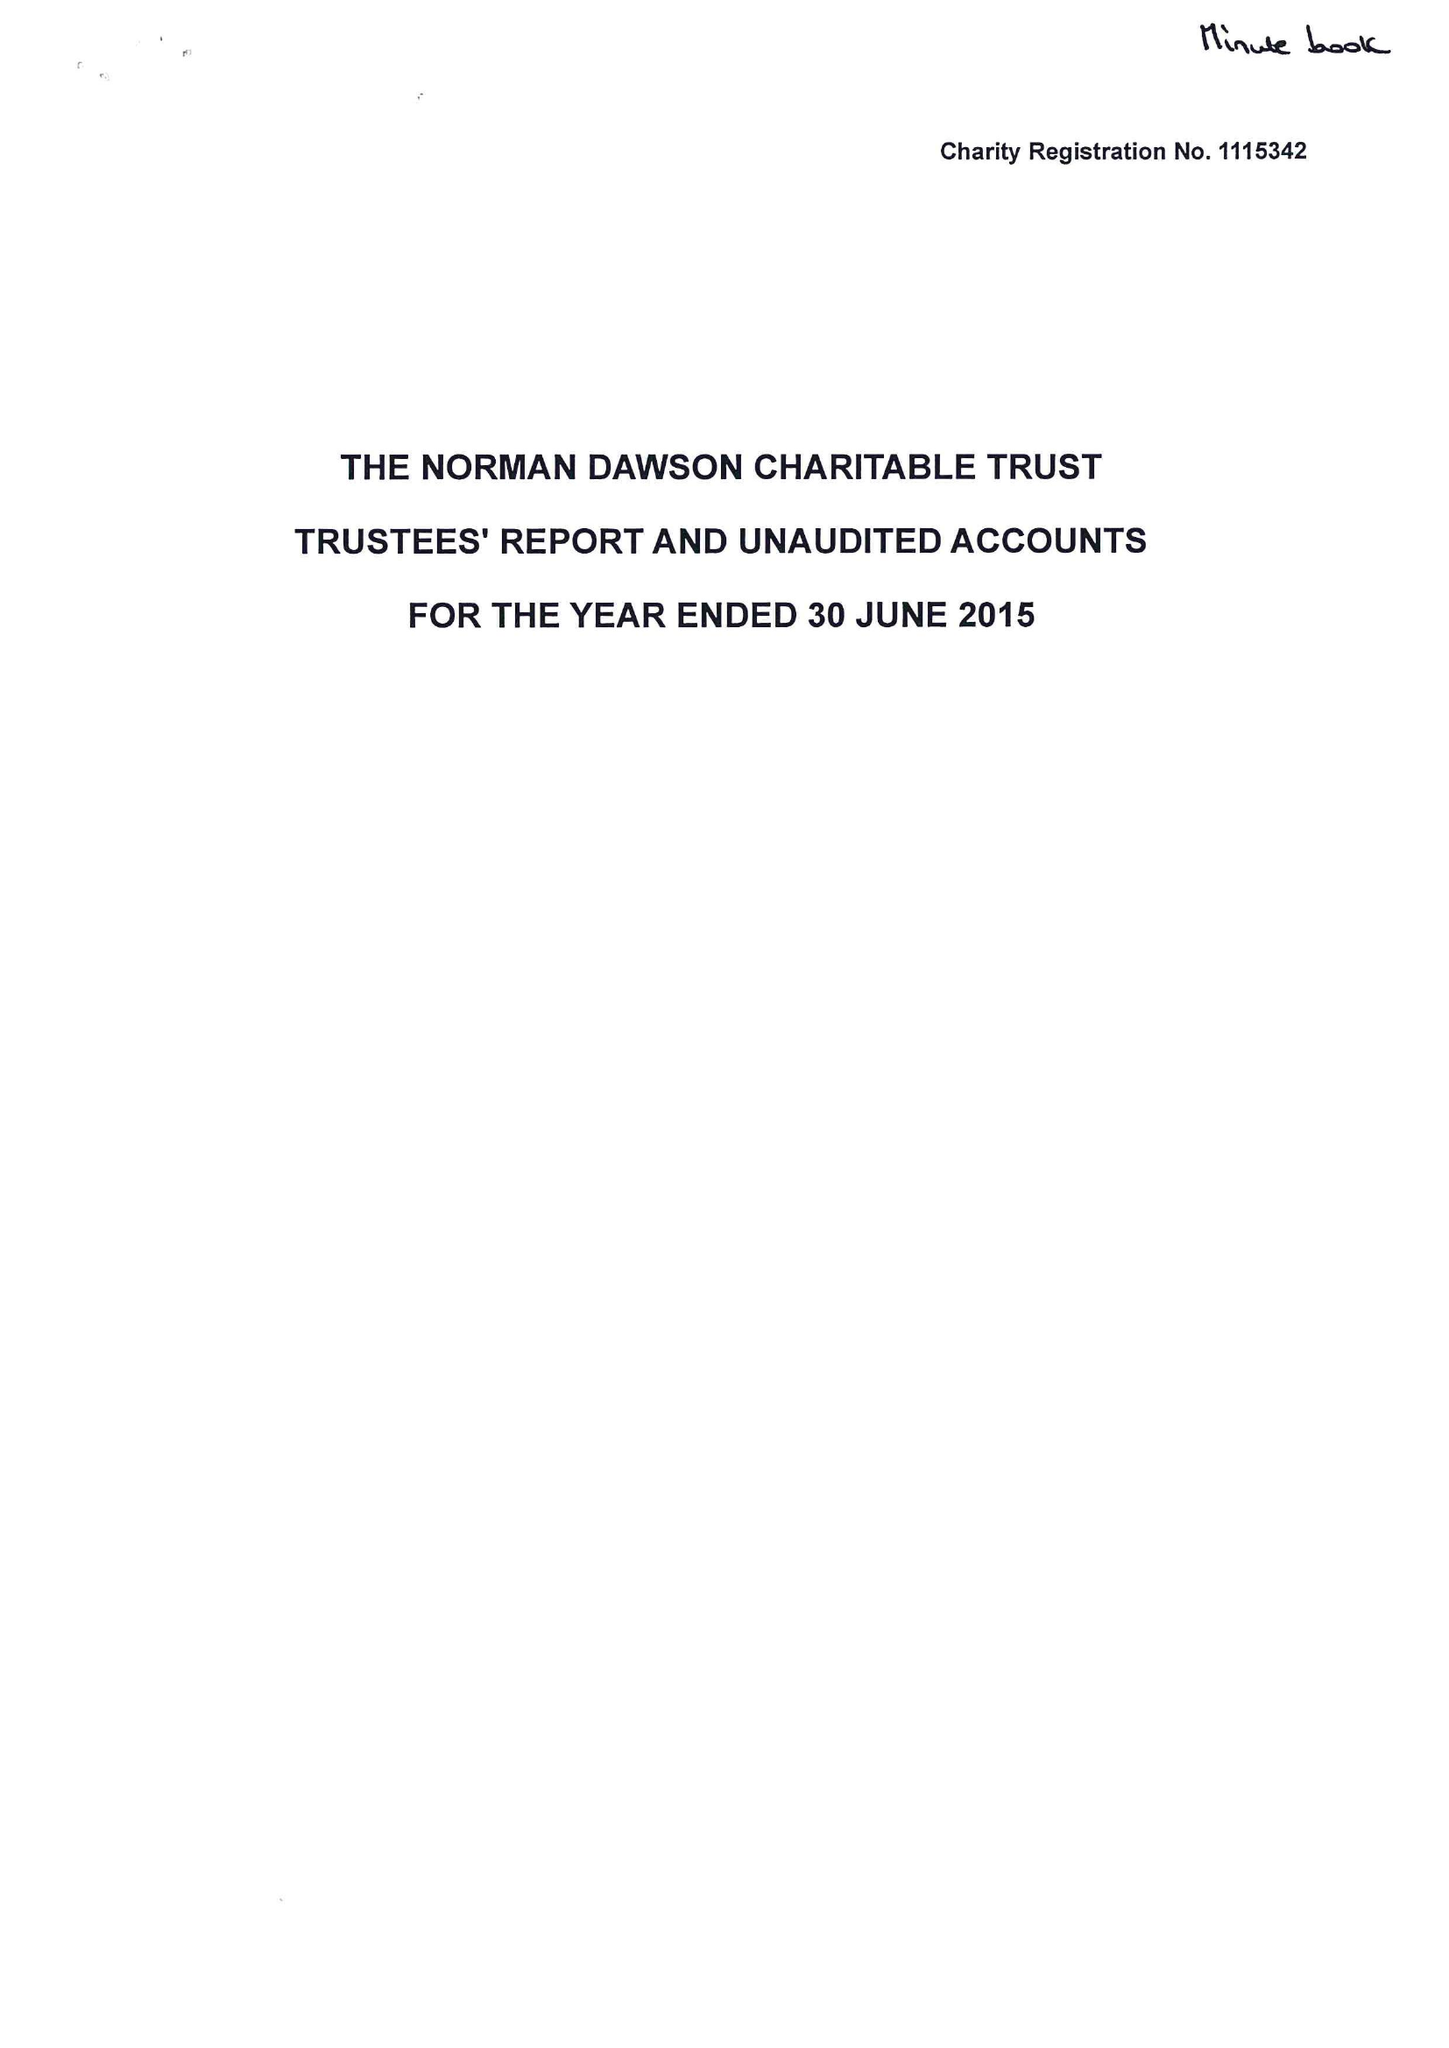What is the value for the report_date?
Answer the question using a single word or phrase. 2015-06-30 